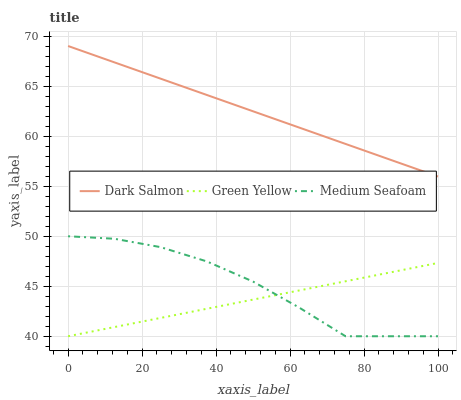Does Green Yellow have the minimum area under the curve?
Answer yes or no. Yes. Does Dark Salmon have the maximum area under the curve?
Answer yes or no. Yes. Does Medium Seafoam have the minimum area under the curve?
Answer yes or no. No. Does Medium Seafoam have the maximum area under the curve?
Answer yes or no. No. Is Dark Salmon the smoothest?
Answer yes or no. Yes. Is Medium Seafoam the roughest?
Answer yes or no. Yes. Is Medium Seafoam the smoothest?
Answer yes or no. No. Is Dark Salmon the roughest?
Answer yes or no. No. Does Green Yellow have the lowest value?
Answer yes or no. Yes. Does Dark Salmon have the lowest value?
Answer yes or no. No. Does Dark Salmon have the highest value?
Answer yes or no. Yes. Does Medium Seafoam have the highest value?
Answer yes or no. No. Is Green Yellow less than Dark Salmon?
Answer yes or no. Yes. Is Dark Salmon greater than Medium Seafoam?
Answer yes or no. Yes. Does Green Yellow intersect Medium Seafoam?
Answer yes or no. Yes. Is Green Yellow less than Medium Seafoam?
Answer yes or no. No. Is Green Yellow greater than Medium Seafoam?
Answer yes or no. No. Does Green Yellow intersect Dark Salmon?
Answer yes or no. No. 